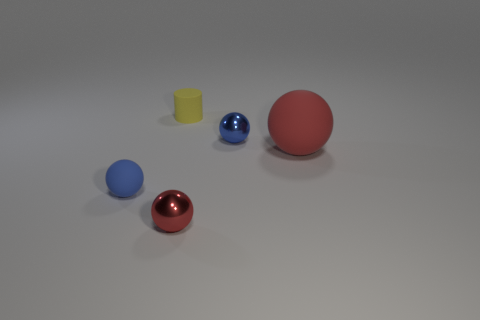Subtract 2 spheres. How many spheres are left? 2 Subtract all tiny blue rubber balls. How many balls are left? 3 Add 3 small balls. How many objects exist? 8 Subtract all purple spheres. Subtract all blue cubes. How many spheres are left? 4 Subtract all cylinders. How many objects are left? 4 Add 4 red objects. How many red objects exist? 6 Subtract 0 brown balls. How many objects are left? 5 Subtract all big cyan cubes. Subtract all tiny red metal spheres. How many objects are left? 4 Add 4 large matte objects. How many large matte objects are left? 5 